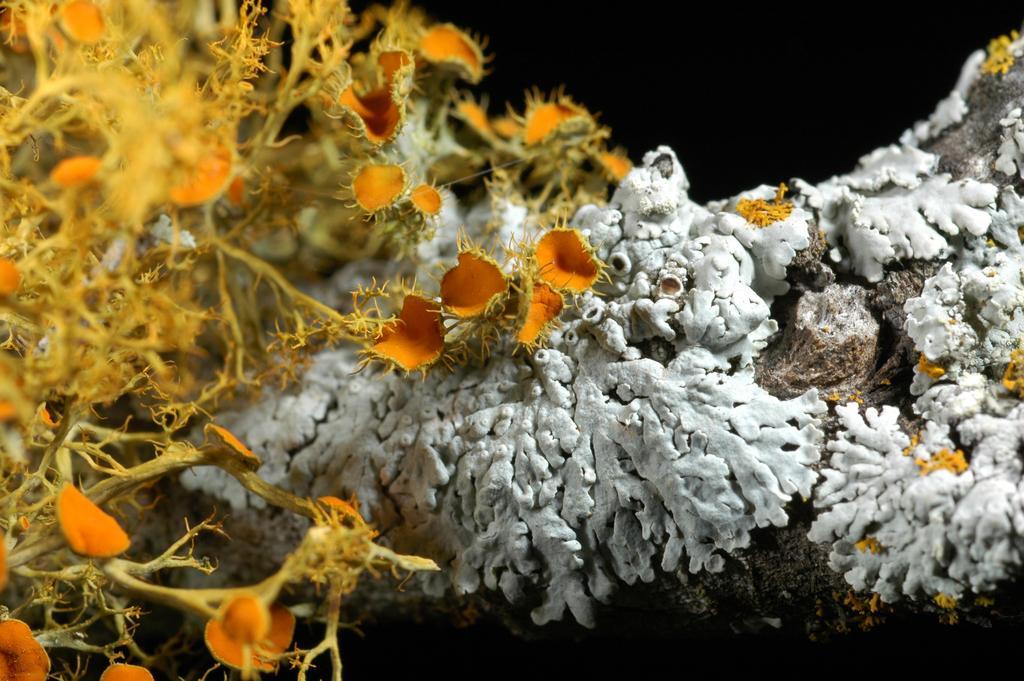How would you summarize this image in a sentence or two? In the image in the center we can see underwater plants,which is in yellow and white color. 